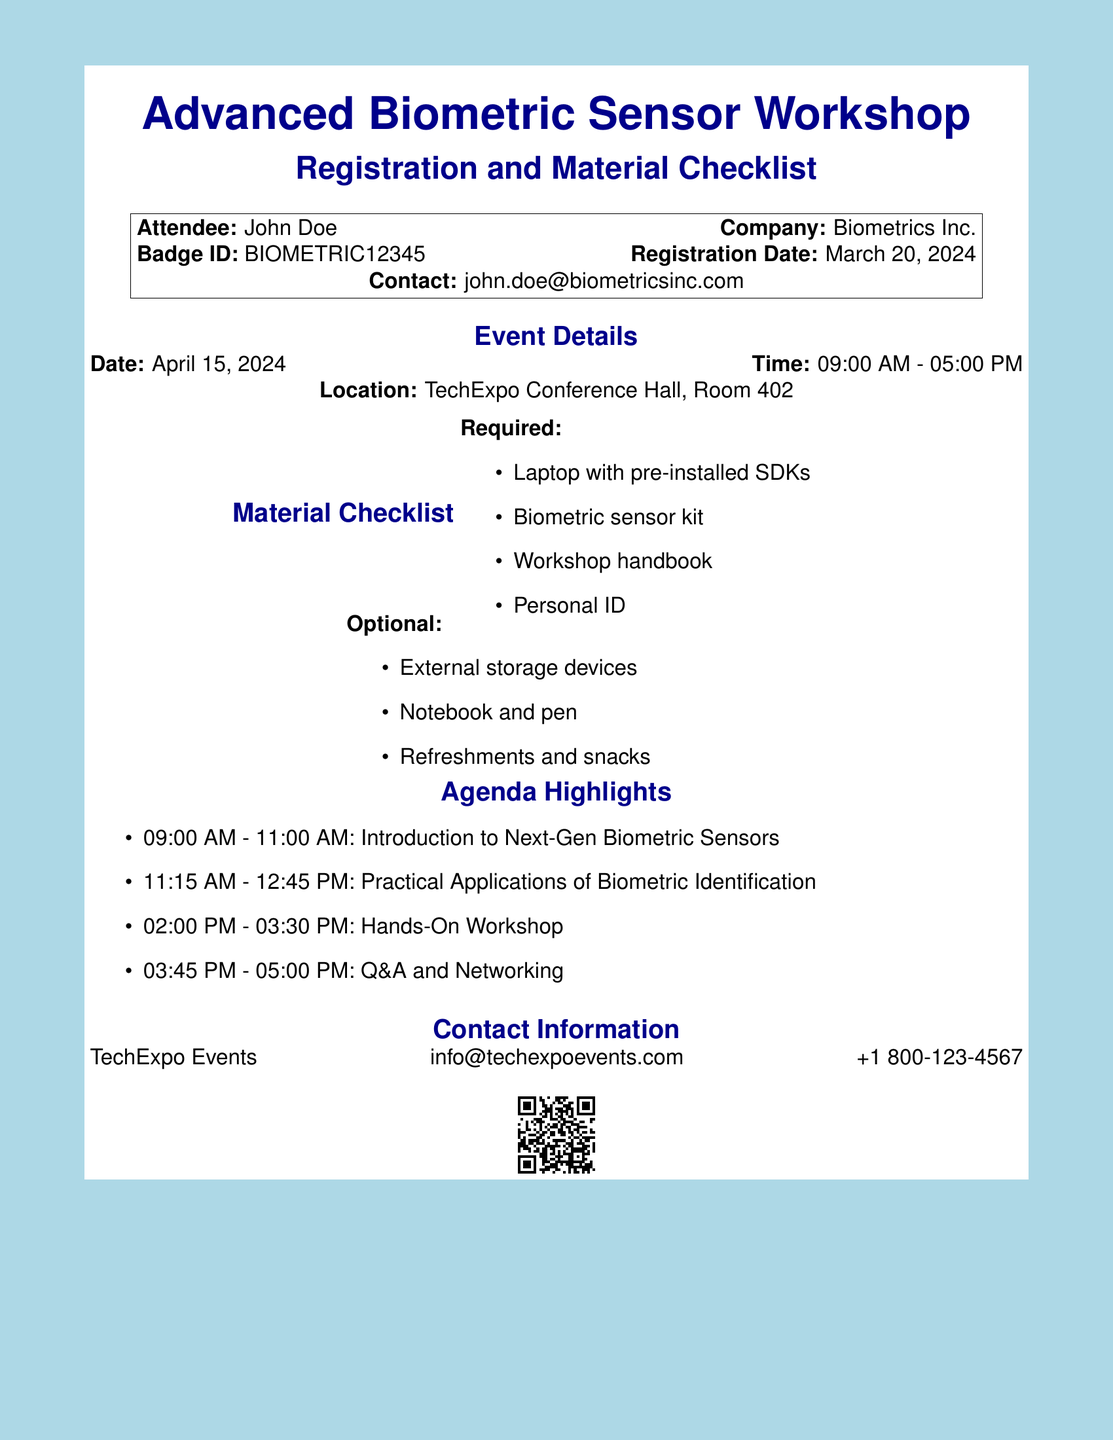What is the attendee's name? The attendee's name is mentioned in the document as part of the registration details.
Answer: John Doe What is the date of the workshop? The workshop date is explicitly listed in the event details section of the document.
Answer: April 15, 2024 What time does the workshop start? The start time of the workshop is indicated in the event details section.
Answer: 09:00 AM What are the required materials for the workshop? The required materials are listed under the material checklist section of the document.
Answer: Laptop with pre-installed SDKs, Biometric sensor kit, Workshop handbook, Personal ID How many agenda highlights are listed? The number of agenda highlights can be determined by counting the items in the agenda section.
Answer: Four What is the location of the workshop? The location can be found in the event details section of the document.
Answer: TechExpo Conference Hall, Room 402 What is the contact email for TechExpo Events? The contact email is provided in the contact information section of the document.
Answer: info@techexpoevents.com What is one optional item mentioned in the material checklist? One optional item is listed in the optional materials section.
Answer: External storage devices What is the badge ID for the attendee? The badge ID is provided as part of the registration details for the attendee.
Answer: BIOMETRIC12345 